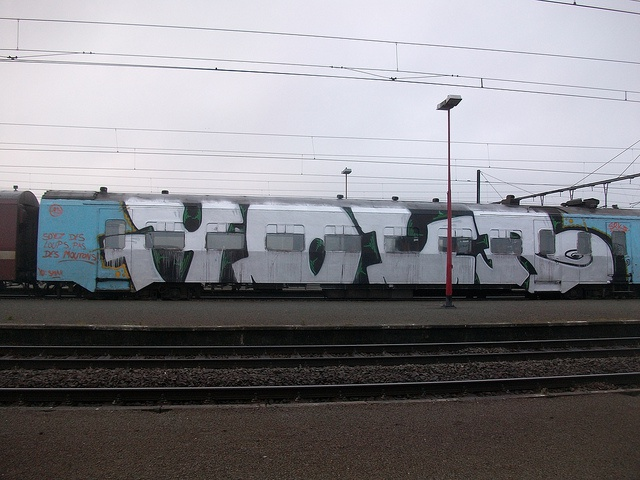Describe the objects in this image and their specific colors. I can see a train in lightgray, black, darkgray, and gray tones in this image. 